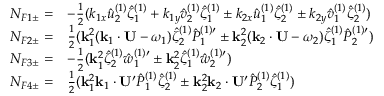Convert formula to latex. <formula><loc_0><loc_0><loc_500><loc_500>\begin{array} { r l } { N _ { F 1 \pm } = } & { - { \frac { 1 } { 2 } } ( k _ { 1 x } \hat { u } _ { 2 } ^ { ( 1 ) } \hat { \zeta } _ { 1 } ^ { ( 1 ) } + k _ { 1 y } \hat { v } _ { 2 } ^ { ( 1 ) } \hat { \zeta } _ { 1 } ^ { ( 1 ) } \pm k _ { 2 x } \hat { u } _ { 1 } ^ { ( 1 ) } \hat { \zeta } _ { 2 } ^ { ( 1 ) } \pm k _ { 2 y } \hat { v } _ { 1 } ^ { ( 1 ) } \hat { \zeta } _ { 2 } ^ { ( 1 ) } ) } \\ { N _ { F 2 \pm } = } & { { \frac { 1 } { 2 } } ( k _ { 1 } ^ { 2 } ( k _ { 1 } \cdot U - \omega _ { 1 } ) \hat { \zeta } _ { 2 } ^ { ( 1 ) } { \hat { P } _ { 1 } ^ { ( 1 ) \prime } } \pm k _ { 2 } ^ { 2 } ( k _ { 2 } \cdot U - \omega _ { 2 } ) \hat { \zeta } _ { 1 } ^ { ( 1 ) } { \hat { P } _ { 2 } ^ { ( 1 ) \prime } } ) } \\ { N _ { F 3 \pm } = } & { - { \frac { 1 } { 2 } } ( k _ { 1 } ^ { 2 } \hat { \zeta } _ { 2 } ^ { ( 1 ) } { \hat { w } _ { 1 } ^ { ( 1 ) \prime } } \pm k _ { 2 } ^ { 2 } \hat { \zeta } _ { 1 } ^ { ( 1 ) } { \hat { w } _ { 2 } ^ { ( 1 ) \prime } } ) } \\ { N _ { F 4 \pm } = } & { { \frac { 1 } { 2 } } ( k _ { 1 } ^ { 2 } k _ { 1 } \cdot U ^ { \prime } \hat { P } _ { 1 } ^ { ( 1 ) } \hat { \zeta } _ { 2 } ^ { ( 1 ) } \pm k _ { 2 } ^ { 2 } k _ { 2 } \cdot U ^ { \prime } \hat { P } _ { 2 } ^ { ( 1 ) } \hat { \zeta } _ { 1 } ^ { ( 1 ) } ) } \end{array}</formula> 